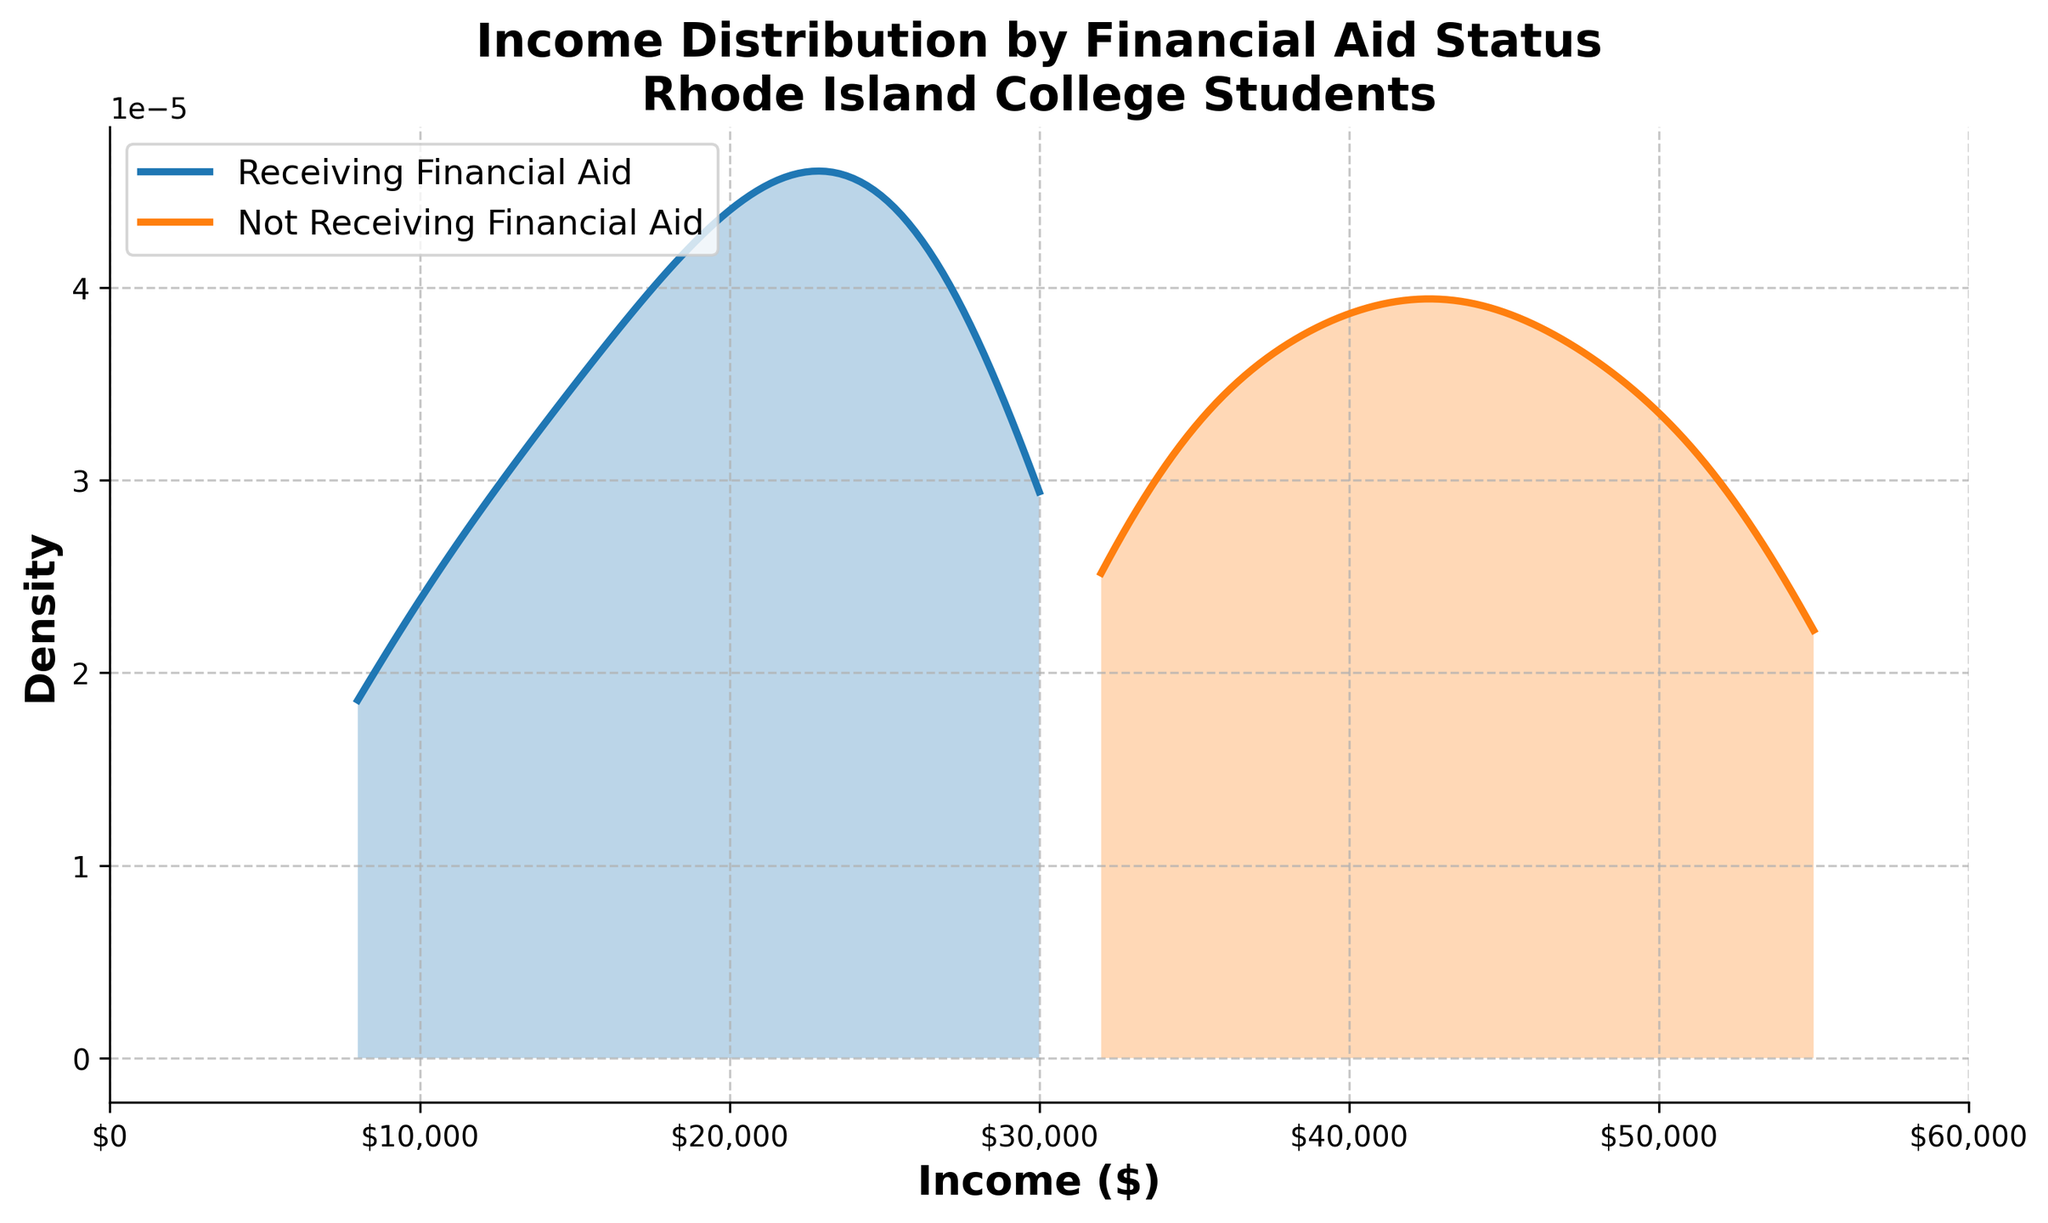What does the title of the plot indicate? The title of the plot provides information on the focus of the figure, which is the income distribution among college students in Rhode Island, segmented by financial aid status.
Answer: Income Distribution by Financial Aid Status, Rhode Island College Students What are the two categories shown in the plot? The plot distinguishes between two groups based on their financial aid status: "Receiving Financial Aid" and "Not Receiving Financial Aid." These categories segment the data for comparison.
Answer: Receiving Financial Aid and Not Receiving Financial Aid What is the income range covered by the x-axis? The x-axis represents the income levels, and its range can be determined by looking at the minimum and maximum values presented on the axis labels. From the figure, it ranges from $0 to $60,000.
Answer: $0 to $60,000 Which group has a higher peak in the density plot? The height of the density curve indicates the concentration of data points. By observing the plot, the group with the curve that reaches higher on the y-axis is identified as having a higher peak. The "Receiving Financial Aid" group has a higher peak.
Answer: Receiving Financial Aid Where do the density peaks for each group occur? Peaks of the density curves represent income ranges with the highest concentrations of data points for each group. The "Receiving Financial Aid" peak occurs around $20,000-$25,000, and for the "Not Receiving Financial Aid," it occurs around $40,000-$45,000.
Answer: $20,000-$25,000 for Receiving Financial Aid and $40,000-$45,000 for Not Receiving Financial Aid What is the approximate median income for students receiving financial aid? The median income can be estimated as the point where the density plot for the "Receiving Financial Aid" group is evenly split, meaning half the area under the curve is on each side. This appears to be around $20,000.
Answer: Approximately $20,000 Do any income values appear in both density curves? Exploring both density curves for overlapping x-values helps identify common income ranges. By looking at the plot, any ranges where both curves intersect indicate shared income values. Both groups have common values around the $0-$30,000 range.
Answer: Yes, around $0-$30,000 In which income range is the density for students not receiving financial aid highest? Identifying the highest density involves finding the peak point of the "Not Receiving Financial Aid" curve. The peak, indicating maximum concentration, is around $40,000-$45,000.
Answer: $40,000-$45,000 Which group shows a wider spread in income distribution? Spread is identified by examining how far the density curves extend along the x-axis. The wider spread suggests greater income variation. The "Not Receiving Financial Aid" group has a wider spread going into higher income levels.
Answer: Not Receiving Financial Aid How does the distribution shape for students receiving financial aid compare to those not receiving it? Comparison involves looking at the shape differences between the two density curves. The "Receiving Financial Aid" curve is more peaked and narrow, while the "Not Receiving Financial Aid" curve is flatter and broader, indicating different income variability.
Answer: Receiving Financial Aid has a narrower, peaked distribution; Not Receiving Financial Aid has a broader, flatter distribution 